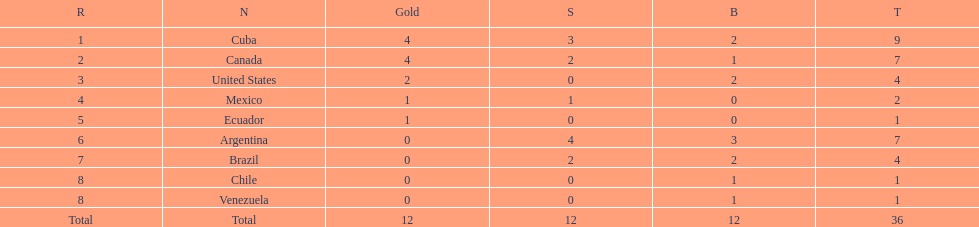Which ranking is mexico? 4. 